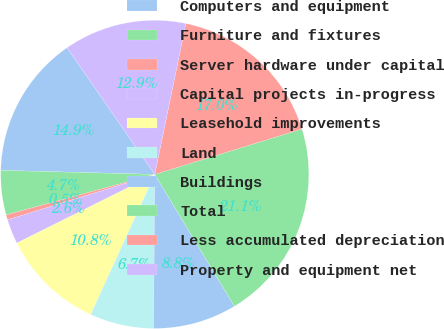Convert chart. <chart><loc_0><loc_0><loc_500><loc_500><pie_chart><fcel>Computers and equipment<fcel>Furniture and fixtures<fcel>Server hardware under capital<fcel>Capital projects in-progress<fcel>Leasehold improvements<fcel>Land<fcel>Buildings<fcel>Total<fcel>Less accumulated depreciation<fcel>Property and equipment net<nl><fcel>14.94%<fcel>4.65%<fcel>0.53%<fcel>2.59%<fcel>10.82%<fcel>6.71%<fcel>8.77%<fcel>21.11%<fcel>17.0%<fcel>12.88%<nl></chart> 